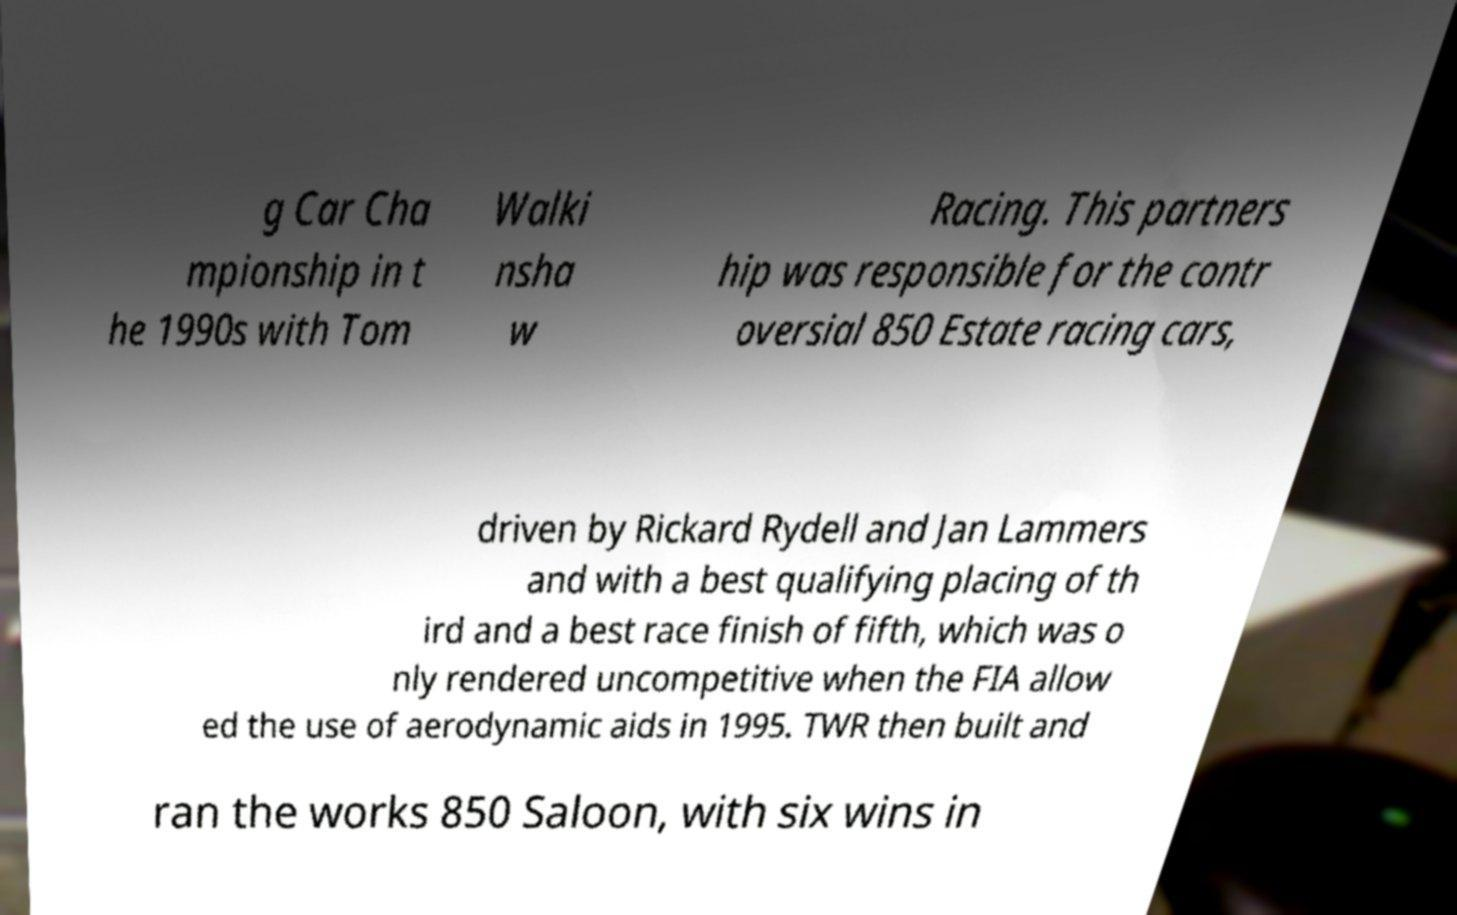Can you accurately transcribe the text from the provided image for me? g Car Cha mpionship in t he 1990s with Tom Walki nsha w Racing. This partners hip was responsible for the contr oversial 850 Estate racing cars, driven by Rickard Rydell and Jan Lammers and with a best qualifying placing of th ird and a best race finish of fifth, which was o nly rendered uncompetitive when the FIA allow ed the use of aerodynamic aids in 1995. TWR then built and ran the works 850 Saloon, with six wins in 